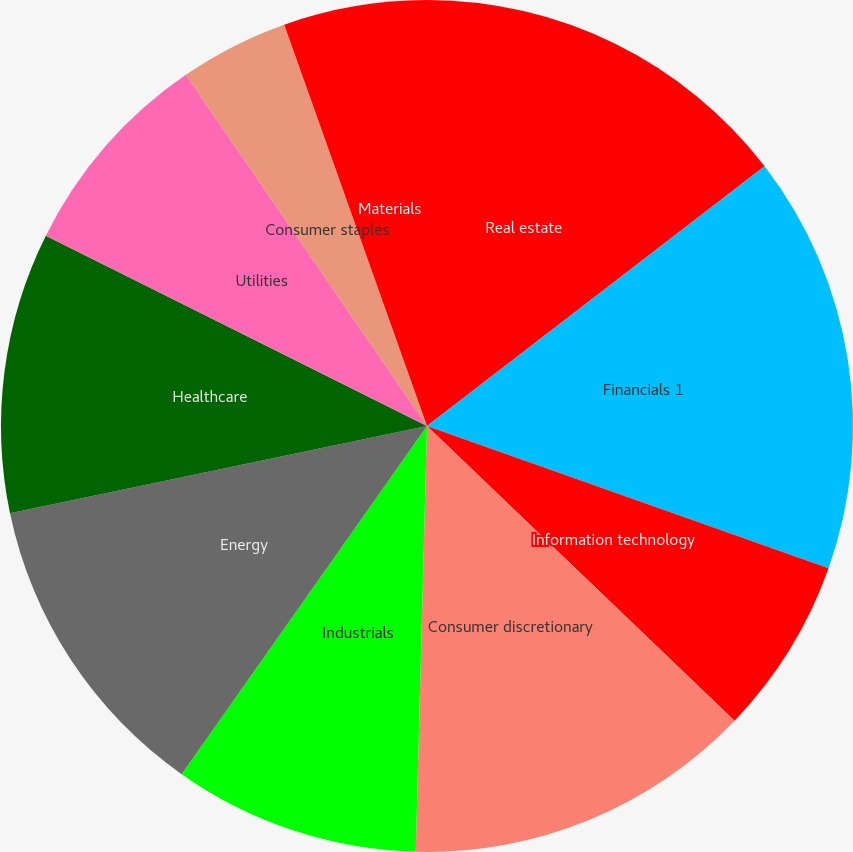Convert chart. <chart><loc_0><loc_0><loc_500><loc_500><pie_chart><fcel>Real estate<fcel>Financials 1<fcel>Information technology<fcel>Consumer discretionary<fcel>Industrials<fcel>Energy<fcel>Healthcare<fcel>Utilities<fcel>Consumer staples<fcel>Materials<nl><fcel>14.56%<fcel>15.86%<fcel>6.74%<fcel>13.26%<fcel>9.35%<fcel>11.95%<fcel>10.65%<fcel>8.05%<fcel>4.14%<fcel>5.44%<nl></chart> 